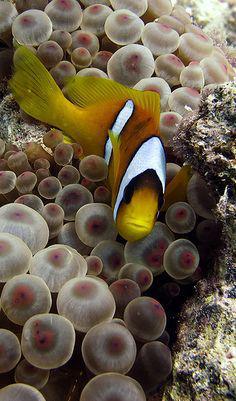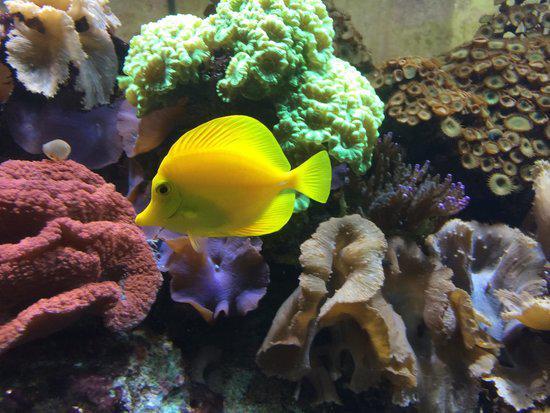The first image is the image on the left, the second image is the image on the right. Considering the images on both sides, is "Each image includes a striped fish swimming near the tendrils of an anemone." valid? Answer yes or no. No. The first image is the image on the left, the second image is the image on the right. For the images shown, is this caption "A yellow, black and white striped fish is swimming around sea plants in the image on the left." true? Answer yes or no. Yes. 